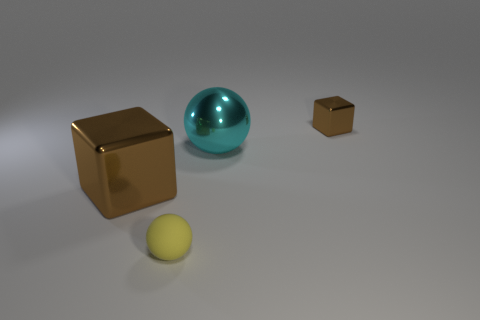Add 3 big brown shiny things. How many objects exist? 7 Subtract all small yellow cylinders. Subtract all large brown cubes. How many objects are left? 3 Add 2 small yellow objects. How many small yellow objects are left? 3 Add 4 tiny shiny cubes. How many tiny shiny cubes exist? 5 Subtract 0 blue cubes. How many objects are left? 4 